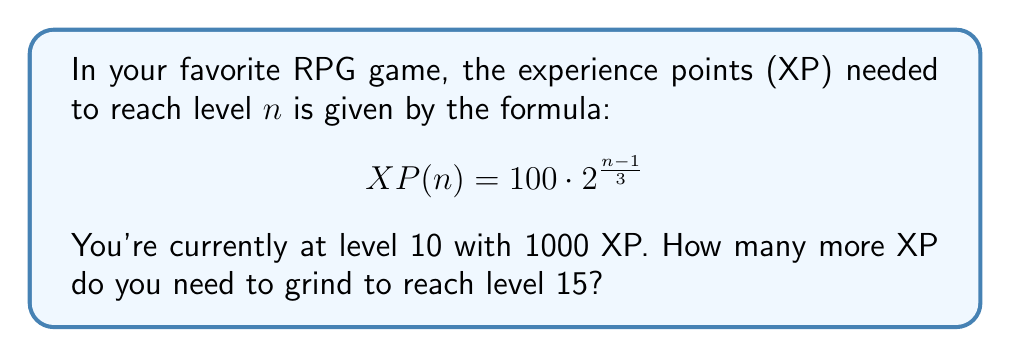Show me your answer to this math problem. Let's approach this step-by-step:

1) First, we need to calculate the XP required for level 15:

   $$ XP(15) = 100 \cdot 2^{\frac{15-1}{3}} = 100 \cdot 2^{\frac{14}{3}} $$

2) We can simplify this:

   $$ XP(15) = 100 \cdot 2^{\frac{14}{3}} = 100 \cdot (2^{\frac{1}{3}})^{14} \approx 3482.2 $$

3) Now, we need to calculate how much XP you already have at level 10:

   $$ XP(10) = 100 \cdot 2^{\frac{10-1}{3}} = 100 \cdot 2^3 = 800 $$

4) However, the question states that you have 1000 XP at level 10, which is 200 XP more than the minimum required for that level.

5) To find out how many more XP you need, we subtract your current XP from the XP required for level 15:

   $$ XP_{needed} = XP(15) - 1000 $$

6) Plugging in the value we calculated for $XP(15)$:

   $$ XP_{needed} \approx 3482.2 - 1000 = 2482.2 $$

7) Since XP is typically represented as whole numbers in games, we round up to the nearest integer.
Answer: You need to gain 2483 more XP to reach level 15. 